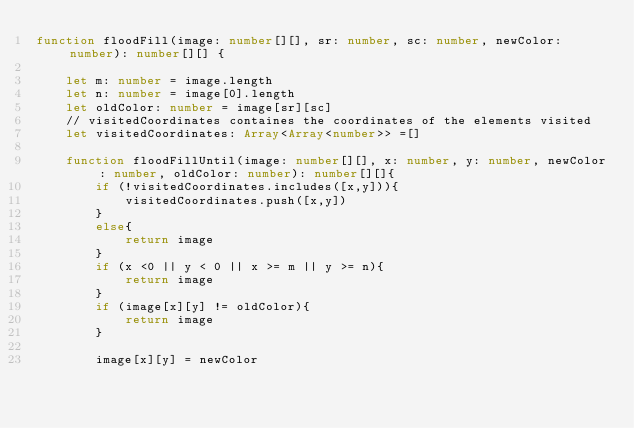<code> <loc_0><loc_0><loc_500><loc_500><_TypeScript_>function floodFill(image: number[][], sr: number, sc: number, newColor: number): number[][] {

    let m: number = image.length
    let n: number = image[0].length
    let oldColor: number = image[sr][sc]
    // visitedCoordinates containes the coordinates of the elements visited 
    let visitedCoordinates: Array<Array<number>> =[]

    function floodFillUntil(image: number[][], x: number, y: number, newColor: number, oldColor: number): number[][]{
        if (!visitedCoordinates.includes([x,y])){
            visitedCoordinates.push([x,y])
        }
        else{
            return image
        }
        if (x <0 || y < 0 || x >= m || y >= n){
            return image
        }
        if (image[x][y] != oldColor){
            return image
        }

        image[x][y] = newColor</code> 